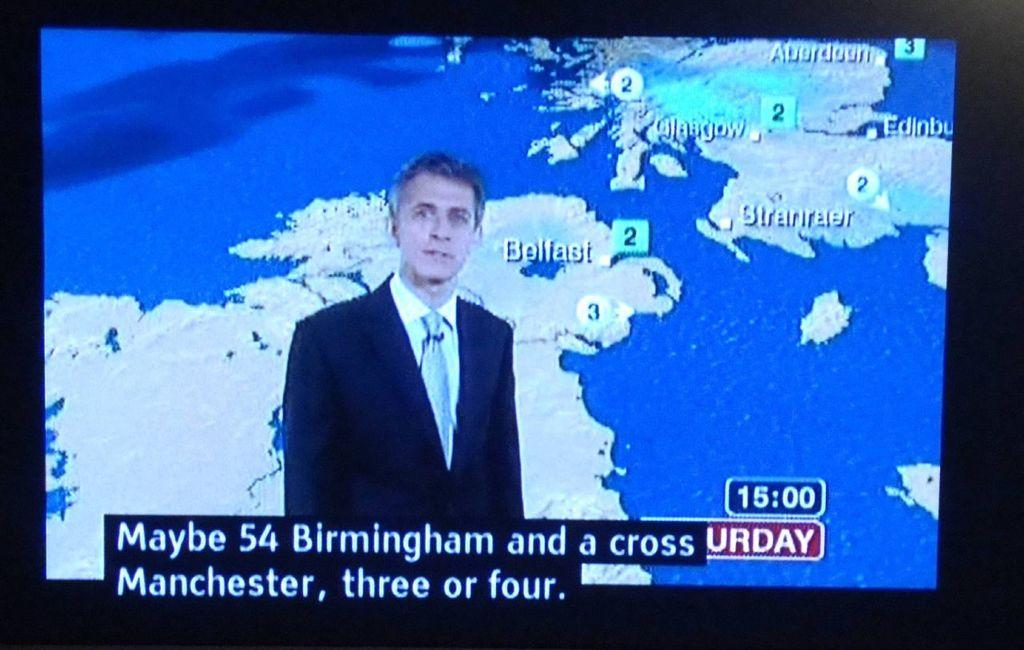<image>
Present a compact description of the photo's key features. A weather announcer is on a television screen, giving the weather report on a Saturday. 